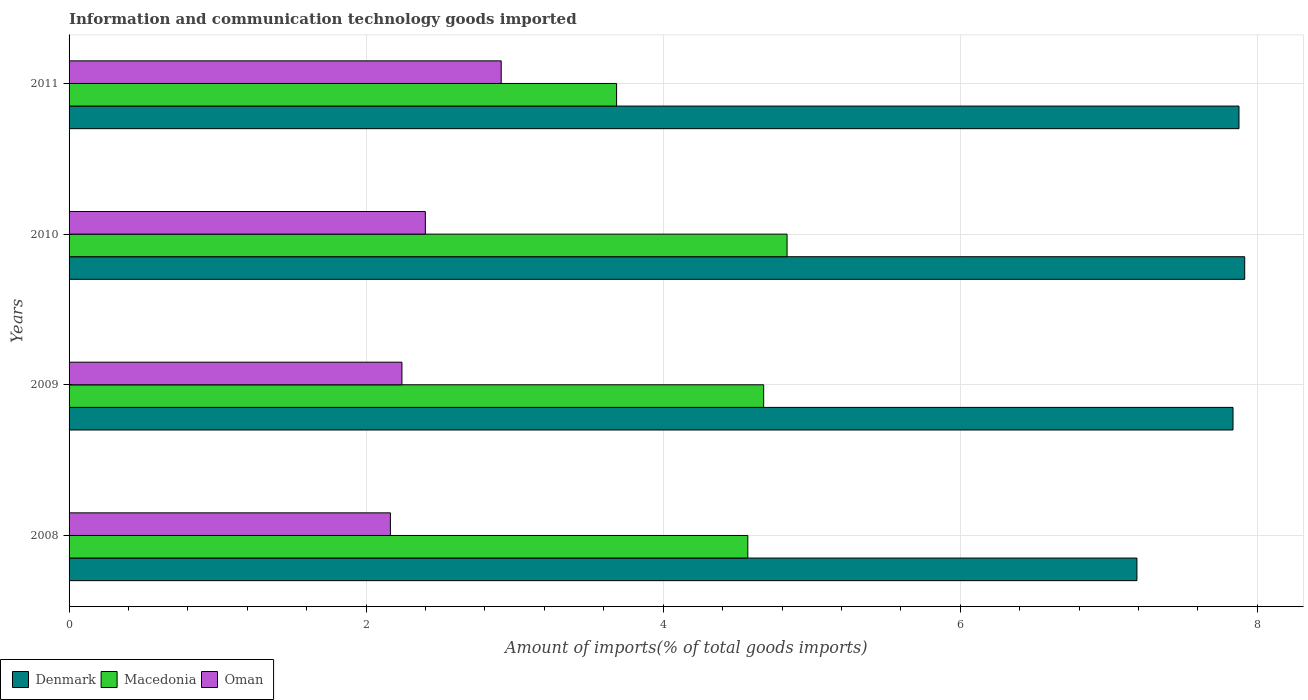How many different coloured bars are there?
Your answer should be compact. 3. How many groups of bars are there?
Your answer should be compact. 4. Are the number of bars per tick equal to the number of legend labels?
Your answer should be very brief. Yes. Are the number of bars on each tick of the Y-axis equal?
Provide a succinct answer. Yes. How many bars are there on the 1st tick from the bottom?
Your answer should be very brief. 3. In how many cases, is the number of bars for a given year not equal to the number of legend labels?
Your answer should be very brief. 0. What is the amount of goods imported in Macedonia in 2008?
Provide a short and direct response. 4.57. Across all years, what is the maximum amount of goods imported in Macedonia?
Make the answer very short. 4.83. Across all years, what is the minimum amount of goods imported in Macedonia?
Ensure brevity in your answer.  3.69. What is the total amount of goods imported in Oman in the graph?
Offer a terse response. 9.71. What is the difference between the amount of goods imported in Denmark in 2008 and that in 2010?
Make the answer very short. -0.73. What is the difference between the amount of goods imported in Oman in 2009 and the amount of goods imported in Denmark in 2008?
Ensure brevity in your answer.  -4.95. What is the average amount of goods imported in Denmark per year?
Provide a succinct answer. 7.7. In the year 2008, what is the difference between the amount of goods imported in Denmark and amount of goods imported in Oman?
Your answer should be compact. 5.03. In how many years, is the amount of goods imported in Macedonia greater than 3.2 %?
Your response must be concise. 4. What is the ratio of the amount of goods imported in Macedonia in 2008 to that in 2010?
Provide a succinct answer. 0.95. Is the difference between the amount of goods imported in Denmark in 2008 and 2010 greater than the difference between the amount of goods imported in Oman in 2008 and 2010?
Your response must be concise. No. What is the difference between the highest and the second highest amount of goods imported in Oman?
Provide a short and direct response. 0.51. What is the difference between the highest and the lowest amount of goods imported in Oman?
Keep it short and to the point. 0.75. In how many years, is the amount of goods imported in Oman greater than the average amount of goods imported in Oman taken over all years?
Your answer should be very brief. 1. Is the sum of the amount of goods imported in Oman in 2008 and 2010 greater than the maximum amount of goods imported in Macedonia across all years?
Your answer should be compact. No. What does the 3rd bar from the top in 2011 represents?
Offer a very short reply. Denmark. What does the 3rd bar from the bottom in 2008 represents?
Provide a succinct answer. Oman. Is it the case that in every year, the sum of the amount of goods imported in Oman and amount of goods imported in Macedonia is greater than the amount of goods imported in Denmark?
Make the answer very short. No. How many bars are there?
Offer a terse response. 12. Are all the bars in the graph horizontal?
Your response must be concise. Yes. What is the difference between two consecutive major ticks on the X-axis?
Ensure brevity in your answer.  2. Are the values on the major ticks of X-axis written in scientific E-notation?
Provide a succinct answer. No. Does the graph contain grids?
Offer a very short reply. Yes. How many legend labels are there?
Ensure brevity in your answer.  3. How are the legend labels stacked?
Keep it short and to the point. Horizontal. What is the title of the graph?
Ensure brevity in your answer.  Information and communication technology goods imported. What is the label or title of the X-axis?
Your response must be concise. Amount of imports(% of total goods imports). What is the label or title of the Y-axis?
Your answer should be very brief. Years. What is the Amount of imports(% of total goods imports) in Denmark in 2008?
Give a very brief answer. 7.19. What is the Amount of imports(% of total goods imports) in Macedonia in 2008?
Ensure brevity in your answer.  4.57. What is the Amount of imports(% of total goods imports) in Oman in 2008?
Your answer should be very brief. 2.16. What is the Amount of imports(% of total goods imports) of Denmark in 2009?
Your answer should be very brief. 7.84. What is the Amount of imports(% of total goods imports) of Macedonia in 2009?
Provide a short and direct response. 4.68. What is the Amount of imports(% of total goods imports) of Oman in 2009?
Make the answer very short. 2.24. What is the Amount of imports(% of total goods imports) in Denmark in 2010?
Ensure brevity in your answer.  7.92. What is the Amount of imports(% of total goods imports) of Macedonia in 2010?
Your answer should be compact. 4.83. What is the Amount of imports(% of total goods imports) in Oman in 2010?
Make the answer very short. 2.4. What is the Amount of imports(% of total goods imports) of Denmark in 2011?
Provide a succinct answer. 7.88. What is the Amount of imports(% of total goods imports) in Macedonia in 2011?
Keep it short and to the point. 3.69. What is the Amount of imports(% of total goods imports) in Oman in 2011?
Your answer should be very brief. 2.91. Across all years, what is the maximum Amount of imports(% of total goods imports) of Denmark?
Provide a short and direct response. 7.92. Across all years, what is the maximum Amount of imports(% of total goods imports) in Macedonia?
Offer a very short reply. 4.83. Across all years, what is the maximum Amount of imports(% of total goods imports) of Oman?
Keep it short and to the point. 2.91. Across all years, what is the minimum Amount of imports(% of total goods imports) of Denmark?
Provide a short and direct response. 7.19. Across all years, what is the minimum Amount of imports(% of total goods imports) of Macedonia?
Your answer should be very brief. 3.69. Across all years, what is the minimum Amount of imports(% of total goods imports) in Oman?
Your answer should be very brief. 2.16. What is the total Amount of imports(% of total goods imports) in Denmark in the graph?
Your response must be concise. 30.82. What is the total Amount of imports(% of total goods imports) of Macedonia in the graph?
Ensure brevity in your answer.  17.77. What is the total Amount of imports(% of total goods imports) of Oman in the graph?
Ensure brevity in your answer.  9.71. What is the difference between the Amount of imports(% of total goods imports) of Denmark in 2008 and that in 2009?
Provide a succinct answer. -0.65. What is the difference between the Amount of imports(% of total goods imports) of Macedonia in 2008 and that in 2009?
Make the answer very short. -0.11. What is the difference between the Amount of imports(% of total goods imports) of Oman in 2008 and that in 2009?
Provide a succinct answer. -0.08. What is the difference between the Amount of imports(% of total goods imports) in Denmark in 2008 and that in 2010?
Give a very brief answer. -0.73. What is the difference between the Amount of imports(% of total goods imports) of Macedonia in 2008 and that in 2010?
Your answer should be compact. -0.26. What is the difference between the Amount of imports(% of total goods imports) of Oman in 2008 and that in 2010?
Offer a very short reply. -0.24. What is the difference between the Amount of imports(% of total goods imports) in Denmark in 2008 and that in 2011?
Offer a very short reply. -0.69. What is the difference between the Amount of imports(% of total goods imports) in Macedonia in 2008 and that in 2011?
Keep it short and to the point. 0.88. What is the difference between the Amount of imports(% of total goods imports) of Oman in 2008 and that in 2011?
Your answer should be compact. -0.75. What is the difference between the Amount of imports(% of total goods imports) of Denmark in 2009 and that in 2010?
Your response must be concise. -0.08. What is the difference between the Amount of imports(% of total goods imports) in Macedonia in 2009 and that in 2010?
Offer a terse response. -0.16. What is the difference between the Amount of imports(% of total goods imports) in Oman in 2009 and that in 2010?
Your response must be concise. -0.16. What is the difference between the Amount of imports(% of total goods imports) in Denmark in 2009 and that in 2011?
Offer a terse response. -0.04. What is the difference between the Amount of imports(% of total goods imports) in Macedonia in 2009 and that in 2011?
Your answer should be compact. 0.99. What is the difference between the Amount of imports(% of total goods imports) of Oman in 2009 and that in 2011?
Provide a short and direct response. -0.67. What is the difference between the Amount of imports(% of total goods imports) of Denmark in 2010 and that in 2011?
Your answer should be compact. 0.04. What is the difference between the Amount of imports(% of total goods imports) of Macedonia in 2010 and that in 2011?
Your response must be concise. 1.15. What is the difference between the Amount of imports(% of total goods imports) in Oman in 2010 and that in 2011?
Offer a very short reply. -0.51. What is the difference between the Amount of imports(% of total goods imports) in Denmark in 2008 and the Amount of imports(% of total goods imports) in Macedonia in 2009?
Give a very brief answer. 2.51. What is the difference between the Amount of imports(% of total goods imports) of Denmark in 2008 and the Amount of imports(% of total goods imports) of Oman in 2009?
Ensure brevity in your answer.  4.95. What is the difference between the Amount of imports(% of total goods imports) of Macedonia in 2008 and the Amount of imports(% of total goods imports) of Oman in 2009?
Ensure brevity in your answer.  2.33. What is the difference between the Amount of imports(% of total goods imports) in Denmark in 2008 and the Amount of imports(% of total goods imports) in Macedonia in 2010?
Your answer should be compact. 2.36. What is the difference between the Amount of imports(% of total goods imports) in Denmark in 2008 and the Amount of imports(% of total goods imports) in Oman in 2010?
Your response must be concise. 4.79. What is the difference between the Amount of imports(% of total goods imports) in Macedonia in 2008 and the Amount of imports(% of total goods imports) in Oman in 2010?
Your answer should be compact. 2.17. What is the difference between the Amount of imports(% of total goods imports) in Denmark in 2008 and the Amount of imports(% of total goods imports) in Macedonia in 2011?
Your response must be concise. 3.5. What is the difference between the Amount of imports(% of total goods imports) in Denmark in 2008 and the Amount of imports(% of total goods imports) in Oman in 2011?
Your answer should be compact. 4.28. What is the difference between the Amount of imports(% of total goods imports) in Macedonia in 2008 and the Amount of imports(% of total goods imports) in Oman in 2011?
Make the answer very short. 1.66. What is the difference between the Amount of imports(% of total goods imports) of Denmark in 2009 and the Amount of imports(% of total goods imports) of Macedonia in 2010?
Provide a succinct answer. 3. What is the difference between the Amount of imports(% of total goods imports) of Denmark in 2009 and the Amount of imports(% of total goods imports) of Oman in 2010?
Your response must be concise. 5.44. What is the difference between the Amount of imports(% of total goods imports) of Macedonia in 2009 and the Amount of imports(% of total goods imports) of Oman in 2010?
Keep it short and to the point. 2.28. What is the difference between the Amount of imports(% of total goods imports) of Denmark in 2009 and the Amount of imports(% of total goods imports) of Macedonia in 2011?
Provide a succinct answer. 4.15. What is the difference between the Amount of imports(% of total goods imports) in Denmark in 2009 and the Amount of imports(% of total goods imports) in Oman in 2011?
Your answer should be compact. 4.93. What is the difference between the Amount of imports(% of total goods imports) of Macedonia in 2009 and the Amount of imports(% of total goods imports) of Oman in 2011?
Provide a succinct answer. 1.77. What is the difference between the Amount of imports(% of total goods imports) in Denmark in 2010 and the Amount of imports(% of total goods imports) in Macedonia in 2011?
Your response must be concise. 4.23. What is the difference between the Amount of imports(% of total goods imports) in Denmark in 2010 and the Amount of imports(% of total goods imports) in Oman in 2011?
Your answer should be very brief. 5.01. What is the difference between the Amount of imports(% of total goods imports) of Macedonia in 2010 and the Amount of imports(% of total goods imports) of Oman in 2011?
Give a very brief answer. 1.92. What is the average Amount of imports(% of total goods imports) of Denmark per year?
Offer a terse response. 7.7. What is the average Amount of imports(% of total goods imports) in Macedonia per year?
Provide a short and direct response. 4.44. What is the average Amount of imports(% of total goods imports) of Oman per year?
Provide a succinct answer. 2.43. In the year 2008, what is the difference between the Amount of imports(% of total goods imports) of Denmark and Amount of imports(% of total goods imports) of Macedonia?
Your response must be concise. 2.62. In the year 2008, what is the difference between the Amount of imports(% of total goods imports) of Denmark and Amount of imports(% of total goods imports) of Oman?
Give a very brief answer. 5.03. In the year 2008, what is the difference between the Amount of imports(% of total goods imports) of Macedonia and Amount of imports(% of total goods imports) of Oman?
Give a very brief answer. 2.41. In the year 2009, what is the difference between the Amount of imports(% of total goods imports) of Denmark and Amount of imports(% of total goods imports) of Macedonia?
Your response must be concise. 3.16. In the year 2009, what is the difference between the Amount of imports(% of total goods imports) of Denmark and Amount of imports(% of total goods imports) of Oman?
Give a very brief answer. 5.6. In the year 2009, what is the difference between the Amount of imports(% of total goods imports) in Macedonia and Amount of imports(% of total goods imports) in Oman?
Offer a very short reply. 2.44. In the year 2010, what is the difference between the Amount of imports(% of total goods imports) of Denmark and Amount of imports(% of total goods imports) of Macedonia?
Provide a succinct answer. 3.08. In the year 2010, what is the difference between the Amount of imports(% of total goods imports) in Denmark and Amount of imports(% of total goods imports) in Oman?
Make the answer very short. 5.52. In the year 2010, what is the difference between the Amount of imports(% of total goods imports) in Macedonia and Amount of imports(% of total goods imports) in Oman?
Keep it short and to the point. 2.44. In the year 2011, what is the difference between the Amount of imports(% of total goods imports) in Denmark and Amount of imports(% of total goods imports) in Macedonia?
Give a very brief answer. 4.19. In the year 2011, what is the difference between the Amount of imports(% of total goods imports) of Denmark and Amount of imports(% of total goods imports) of Oman?
Provide a succinct answer. 4.97. In the year 2011, what is the difference between the Amount of imports(% of total goods imports) of Macedonia and Amount of imports(% of total goods imports) of Oman?
Provide a succinct answer. 0.78. What is the ratio of the Amount of imports(% of total goods imports) of Denmark in 2008 to that in 2009?
Your answer should be very brief. 0.92. What is the ratio of the Amount of imports(% of total goods imports) of Macedonia in 2008 to that in 2009?
Ensure brevity in your answer.  0.98. What is the ratio of the Amount of imports(% of total goods imports) of Oman in 2008 to that in 2009?
Make the answer very short. 0.97. What is the ratio of the Amount of imports(% of total goods imports) in Denmark in 2008 to that in 2010?
Give a very brief answer. 0.91. What is the ratio of the Amount of imports(% of total goods imports) of Macedonia in 2008 to that in 2010?
Your answer should be very brief. 0.95. What is the ratio of the Amount of imports(% of total goods imports) in Oman in 2008 to that in 2010?
Your response must be concise. 0.9. What is the ratio of the Amount of imports(% of total goods imports) in Denmark in 2008 to that in 2011?
Offer a terse response. 0.91. What is the ratio of the Amount of imports(% of total goods imports) in Macedonia in 2008 to that in 2011?
Make the answer very short. 1.24. What is the ratio of the Amount of imports(% of total goods imports) in Oman in 2008 to that in 2011?
Your answer should be very brief. 0.74. What is the ratio of the Amount of imports(% of total goods imports) in Denmark in 2009 to that in 2010?
Offer a terse response. 0.99. What is the ratio of the Amount of imports(% of total goods imports) of Macedonia in 2009 to that in 2010?
Offer a terse response. 0.97. What is the ratio of the Amount of imports(% of total goods imports) of Oman in 2009 to that in 2010?
Your response must be concise. 0.93. What is the ratio of the Amount of imports(% of total goods imports) of Denmark in 2009 to that in 2011?
Make the answer very short. 0.99. What is the ratio of the Amount of imports(% of total goods imports) in Macedonia in 2009 to that in 2011?
Offer a very short reply. 1.27. What is the ratio of the Amount of imports(% of total goods imports) in Oman in 2009 to that in 2011?
Provide a succinct answer. 0.77. What is the ratio of the Amount of imports(% of total goods imports) in Macedonia in 2010 to that in 2011?
Offer a very short reply. 1.31. What is the ratio of the Amount of imports(% of total goods imports) of Oman in 2010 to that in 2011?
Provide a succinct answer. 0.82. What is the difference between the highest and the second highest Amount of imports(% of total goods imports) of Denmark?
Your answer should be compact. 0.04. What is the difference between the highest and the second highest Amount of imports(% of total goods imports) in Macedonia?
Keep it short and to the point. 0.16. What is the difference between the highest and the second highest Amount of imports(% of total goods imports) of Oman?
Make the answer very short. 0.51. What is the difference between the highest and the lowest Amount of imports(% of total goods imports) in Denmark?
Your answer should be very brief. 0.73. What is the difference between the highest and the lowest Amount of imports(% of total goods imports) in Macedonia?
Your answer should be compact. 1.15. What is the difference between the highest and the lowest Amount of imports(% of total goods imports) of Oman?
Provide a short and direct response. 0.75. 